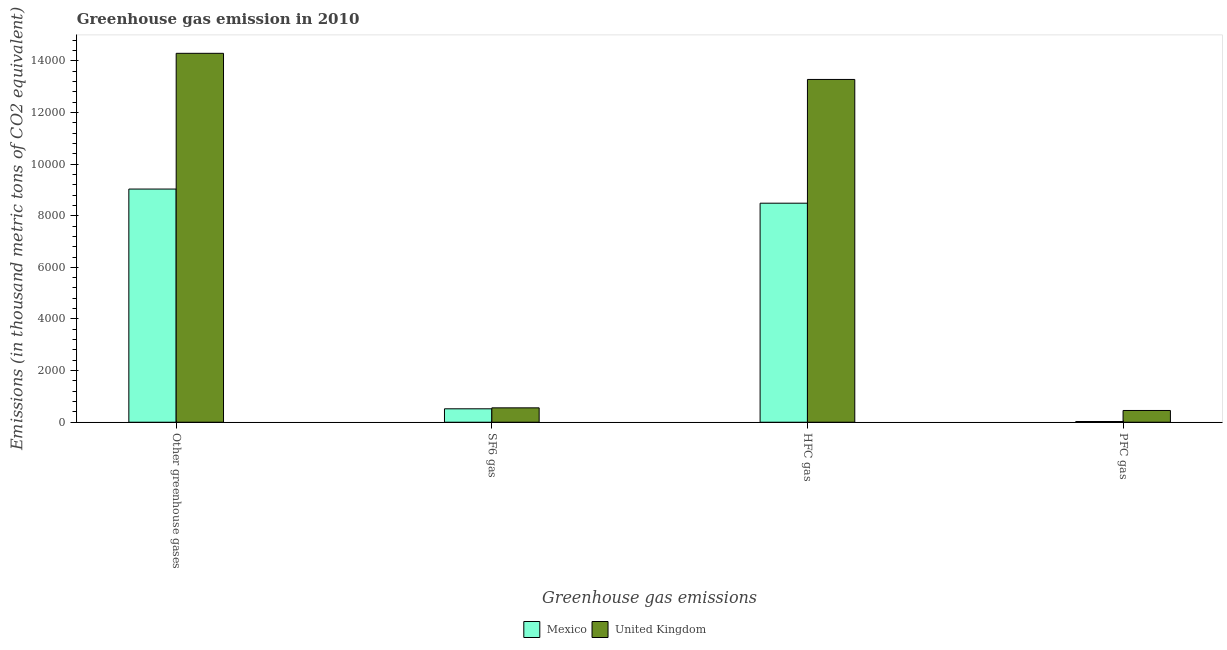How many different coloured bars are there?
Offer a terse response. 2. Are the number of bars on each tick of the X-axis equal?
Your answer should be compact. Yes. How many bars are there on the 2nd tick from the left?
Your answer should be very brief. 2. How many bars are there on the 3rd tick from the right?
Your answer should be compact. 2. What is the label of the 1st group of bars from the left?
Your response must be concise. Other greenhouse gases. What is the emission of greenhouse gases in Mexico?
Your answer should be very brief. 9033. Across all countries, what is the maximum emission of sf6 gas?
Provide a succinct answer. 557. Across all countries, what is the minimum emission of greenhouse gases?
Give a very brief answer. 9033. In which country was the emission of pfc gas maximum?
Offer a very short reply. United Kingdom. What is the total emission of hfc gas in the graph?
Provide a succinct answer. 2.18e+04. What is the difference between the emission of pfc gas in Mexico and that in United Kingdom?
Provide a succinct answer. -427. What is the difference between the emission of greenhouse gases in United Kingdom and the emission of sf6 gas in Mexico?
Keep it short and to the point. 1.38e+04. What is the average emission of greenhouse gases per country?
Provide a succinct answer. 1.17e+04. What is the difference between the emission of greenhouse gases and emission of sf6 gas in United Kingdom?
Your answer should be very brief. 1.37e+04. In how many countries, is the emission of pfc gas greater than 11200 thousand metric tons?
Offer a very short reply. 0. What is the ratio of the emission of sf6 gas in Mexico to that in United Kingdom?
Give a very brief answer. 0.93. What is the difference between the highest and the second highest emission of greenhouse gases?
Ensure brevity in your answer.  5258. What is the difference between the highest and the lowest emission of hfc gas?
Your answer should be compact. 4794. What does the 1st bar from the left in PFC gas represents?
Make the answer very short. Mexico. What does the 1st bar from the right in SF6 gas represents?
Make the answer very short. United Kingdom. How many bars are there?
Provide a succinct answer. 8. Are all the bars in the graph horizontal?
Provide a succinct answer. No. How many countries are there in the graph?
Offer a terse response. 2. Does the graph contain grids?
Your answer should be very brief. No. How are the legend labels stacked?
Make the answer very short. Horizontal. What is the title of the graph?
Offer a very short reply. Greenhouse gas emission in 2010. What is the label or title of the X-axis?
Your answer should be compact. Greenhouse gas emissions. What is the label or title of the Y-axis?
Offer a very short reply. Emissions (in thousand metric tons of CO2 equivalent). What is the Emissions (in thousand metric tons of CO2 equivalent) in Mexico in Other greenhouse gases?
Offer a very short reply. 9033. What is the Emissions (in thousand metric tons of CO2 equivalent) of United Kingdom in Other greenhouse gases?
Keep it short and to the point. 1.43e+04. What is the Emissions (in thousand metric tons of CO2 equivalent) of Mexico in SF6 gas?
Give a very brief answer. 520. What is the Emissions (in thousand metric tons of CO2 equivalent) in United Kingdom in SF6 gas?
Your answer should be very brief. 557. What is the Emissions (in thousand metric tons of CO2 equivalent) in Mexico in HFC gas?
Keep it short and to the point. 8485. What is the Emissions (in thousand metric tons of CO2 equivalent) of United Kingdom in HFC gas?
Provide a short and direct response. 1.33e+04. What is the Emissions (in thousand metric tons of CO2 equivalent) of United Kingdom in PFC gas?
Give a very brief answer. 455. Across all Greenhouse gas emissions, what is the maximum Emissions (in thousand metric tons of CO2 equivalent) of Mexico?
Your answer should be compact. 9033. Across all Greenhouse gas emissions, what is the maximum Emissions (in thousand metric tons of CO2 equivalent) of United Kingdom?
Your answer should be very brief. 1.43e+04. Across all Greenhouse gas emissions, what is the minimum Emissions (in thousand metric tons of CO2 equivalent) in Mexico?
Keep it short and to the point. 28. Across all Greenhouse gas emissions, what is the minimum Emissions (in thousand metric tons of CO2 equivalent) in United Kingdom?
Offer a very short reply. 455. What is the total Emissions (in thousand metric tons of CO2 equivalent) of Mexico in the graph?
Keep it short and to the point. 1.81e+04. What is the total Emissions (in thousand metric tons of CO2 equivalent) of United Kingdom in the graph?
Ensure brevity in your answer.  2.86e+04. What is the difference between the Emissions (in thousand metric tons of CO2 equivalent) of Mexico in Other greenhouse gases and that in SF6 gas?
Keep it short and to the point. 8513. What is the difference between the Emissions (in thousand metric tons of CO2 equivalent) in United Kingdom in Other greenhouse gases and that in SF6 gas?
Your response must be concise. 1.37e+04. What is the difference between the Emissions (in thousand metric tons of CO2 equivalent) of Mexico in Other greenhouse gases and that in HFC gas?
Ensure brevity in your answer.  548. What is the difference between the Emissions (in thousand metric tons of CO2 equivalent) in United Kingdom in Other greenhouse gases and that in HFC gas?
Your answer should be very brief. 1012. What is the difference between the Emissions (in thousand metric tons of CO2 equivalent) in Mexico in Other greenhouse gases and that in PFC gas?
Your response must be concise. 9005. What is the difference between the Emissions (in thousand metric tons of CO2 equivalent) in United Kingdom in Other greenhouse gases and that in PFC gas?
Keep it short and to the point. 1.38e+04. What is the difference between the Emissions (in thousand metric tons of CO2 equivalent) in Mexico in SF6 gas and that in HFC gas?
Offer a terse response. -7965. What is the difference between the Emissions (in thousand metric tons of CO2 equivalent) of United Kingdom in SF6 gas and that in HFC gas?
Give a very brief answer. -1.27e+04. What is the difference between the Emissions (in thousand metric tons of CO2 equivalent) in Mexico in SF6 gas and that in PFC gas?
Give a very brief answer. 492. What is the difference between the Emissions (in thousand metric tons of CO2 equivalent) in United Kingdom in SF6 gas and that in PFC gas?
Offer a very short reply. 102. What is the difference between the Emissions (in thousand metric tons of CO2 equivalent) in Mexico in HFC gas and that in PFC gas?
Give a very brief answer. 8457. What is the difference between the Emissions (in thousand metric tons of CO2 equivalent) of United Kingdom in HFC gas and that in PFC gas?
Offer a very short reply. 1.28e+04. What is the difference between the Emissions (in thousand metric tons of CO2 equivalent) in Mexico in Other greenhouse gases and the Emissions (in thousand metric tons of CO2 equivalent) in United Kingdom in SF6 gas?
Your answer should be compact. 8476. What is the difference between the Emissions (in thousand metric tons of CO2 equivalent) of Mexico in Other greenhouse gases and the Emissions (in thousand metric tons of CO2 equivalent) of United Kingdom in HFC gas?
Your response must be concise. -4246. What is the difference between the Emissions (in thousand metric tons of CO2 equivalent) of Mexico in Other greenhouse gases and the Emissions (in thousand metric tons of CO2 equivalent) of United Kingdom in PFC gas?
Keep it short and to the point. 8578. What is the difference between the Emissions (in thousand metric tons of CO2 equivalent) of Mexico in SF6 gas and the Emissions (in thousand metric tons of CO2 equivalent) of United Kingdom in HFC gas?
Your answer should be very brief. -1.28e+04. What is the difference between the Emissions (in thousand metric tons of CO2 equivalent) in Mexico in SF6 gas and the Emissions (in thousand metric tons of CO2 equivalent) in United Kingdom in PFC gas?
Your response must be concise. 65. What is the difference between the Emissions (in thousand metric tons of CO2 equivalent) in Mexico in HFC gas and the Emissions (in thousand metric tons of CO2 equivalent) in United Kingdom in PFC gas?
Provide a short and direct response. 8030. What is the average Emissions (in thousand metric tons of CO2 equivalent) in Mexico per Greenhouse gas emissions?
Give a very brief answer. 4516.5. What is the average Emissions (in thousand metric tons of CO2 equivalent) in United Kingdom per Greenhouse gas emissions?
Your response must be concise. 7145.5. What is the difference between the Emissions (in thousand metric tons of CO2 equivalent) of Mexico and Emissions (in thousand metric tons of CO2 equivalent) of United Kingdom in Other greenhouse gases?
Your answer should be very brief. -5258. What is the difference between the Emissions (in thousand metric tons of CO2 equivalent) of Mexico and Emissions (in thousand metric tons of CO2 equivalent) of United Kingdom in SF6 gas?
Keep it short and to the point. -37. What is the difference between the Emissions (in thousand metric tons of CO2 equivalent) of Mexico and Emissions (in thousand metric tons of CO2 equivalent) of United Kingdom in HFC gas?
Offer a terse response. -4794. What is the difference between the Emissions (in thousand metric tons of CO2 equivalent) in Mexico and Emissions (in thousand metric tons of CO2 equivalent) in United Kingdom in PFC gas?
Offer a terse response. -427. What is the ratio of the Emissions (in thousand metric tons of CO2 equivalent) of Mexico in Other greenhouse gases to that in SF6 gas?
Keep it short and to the point. 17.37. What is the ratio of the Emissions (in thousand metric tons of CO2 equivalent) of United Kingdom in Other greenhouse gases to that in SF6 gas?
Give a very brief answer. 25.66. What is the ratio of the Emissions (in thousand metric tons of CO2 equivalent) of Mexico in Other greenhouse gases to that in HFC gas?
Ensure brevity in your answer.  1.06. What is the ratio of the Emissions (in thousand metric tons of CO2 equivalent) in United Kingdom in Other greenhouse gases to that in HFC gas?
Provide a succinct answer. 1.08. What is the ratio of the Emissions (in thousand metric tons of CO2 equivalent) of Mexico in Other greenhouse gases to that in PFC gas?
Your answer should be compact. 322.61. What is the ratio of the Emissions (in thousand metric tons of CO2 equivalent) in United Kingdom in Other greenhouse gases to that in PFC gas?
Your answer should be compact. 31.41. What is the ratio of the Emissions (in thousand metric tons of CO2 equivalent) of Mexico in SF6 gas to that in HFC gas?
Give a very brief answer. 0.06. What is the ratio of the Emissions (in thousand metric tons of CO2 equivalent) of United Kingdom in SF6 gas to that in HFC gas?
Offer a very short reply. 0.04. What is the ratio of the Emissions (in thousand metric tons of CO2 equivalent) in Mexico in SF6 gas to that in PFC gas?
Your answer should be compact. 18.57. What is the ratio of the Emissions (in thousand metric tons of CO2 equivalent) of United Kingdom in SF6 gas to that in PFC gas?
Ensure brevity in your answer.  1.22. What is the ratio of the Emissions (in thousand metric tons of CO2 equivalent) of Mexico in HFC gas to that in PFC gas?
Your answer should be compact. 303.04. What is the ratio of the Emissions (in thousand metric tons of CO2 equivalent) of United Kingdom in HFC gas to that in PFC gas?
Provide a succinct answer. 29.18. What is the difference between the highest and the second highest Emissions (in thousand metric tons of CO2 equivalent) in Mexico?
Provide a short and direct response. 548. What is the difference between the highest and the second highest Emissions (in thousand metric tons of CO2 equivalent) in United Kingdom?
Provide a short and direct response. 1012. What is the difference between the highest and the lowest Emissions (in thousand metric tons of CO2 equivalent) of Mexico?
Make the answer very short. 9005. What is the difference between the highest and the lowest Emissions (in thousand metric tons of CO2 equivalent) of United Kingdom?
Offer a terse response. 1.38e+04. 